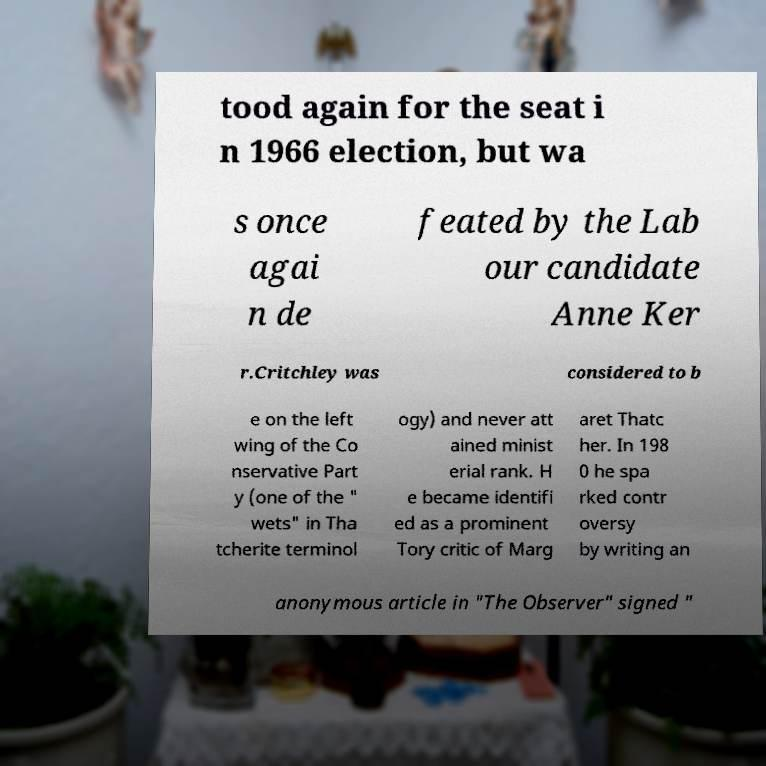What messages or text are displayed in this image? I need them in a readable, typed format. tood again for the seat i n 1966 election, but wa s once agai n de feated by the Lab our candidate Anne Ker r.Critchley was considered to b e on the left wing of the Co nservative Part y (one of the " wets" in Tha tcherite terminol ogy) and never att ained minist erial rank. H e became identifi ed as a prominent Tory critic of Marg aret Thatc her. In 198 0 he spa rked contr oversy by writing an anonymous article in "The Observer" signed " 